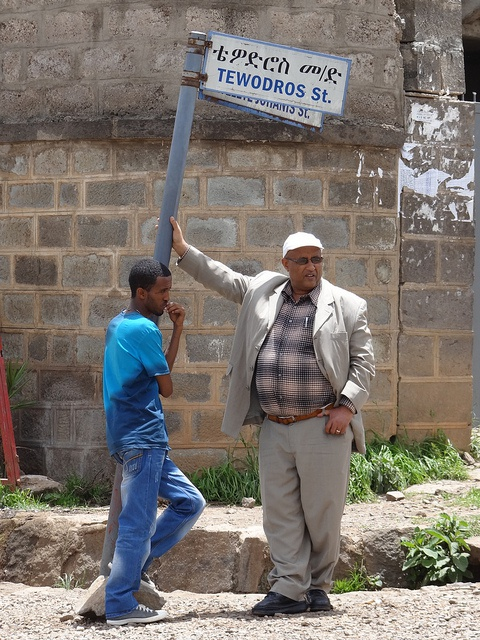Describe the objects in this image and their specific colors. I can see people in gray, darkgray, black, and white tones and people in gray, navy, blue, darkblue, and black tones in this image. 